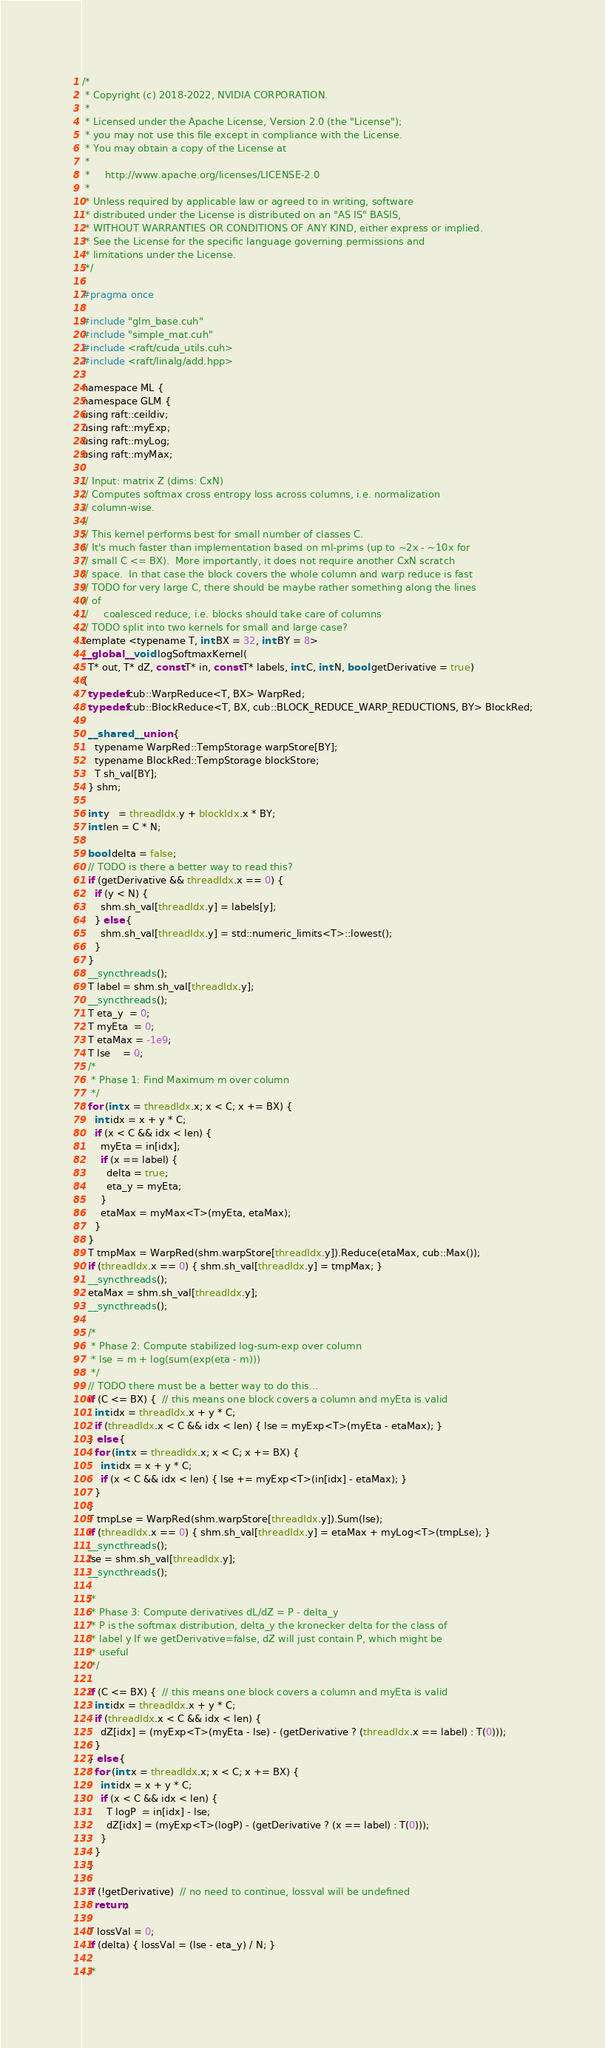Convert code to text. <code><loc_0><loc_0><loc_500><loc_500><_Cuda_>/*
 * Copyright (c) 2018-2022, NVIDIA CORPORATION.
 *
 * Licensed under the Apache License, Version 2.0 (the "License");
 * you may not use this file except in compliance with the License.
 * You may obtain a copy of the License at
 *
 *     http://www.apache.org/licenses/LICENSE-2.0
 *
 * Unless required by applicable law or agreed to in writing, software
 * distributed under the License is distributed on an "AS IS" BASIS,
 * WITHOUT WARRANTIES OR CONDITIONS OF ANY KIND, either express or implied.
 * See the License for the specific language governing permissions and
 * limitations under the License.
 */

#pragma once

#include "glm_base.cuh"
#include "simple_mat.cuh"
#include <raft/cuda_utils.cuh>
#include <raft/linalg/add.hpp>

namespace ML {
namespace GLM {
using raft::ceildiv;
using raft::myExp;
using raft::myLog;
using raft::myMax;

// Input: matrix Z (dims: CxN)
// Computes softmax cross entropy loss across columns, i.e. normalization
// column-wise.
//
// This kernel performs best for small number of classes C.
// It's much faster than implementation based on ml-prims (up to ~2x - ~10x for
// small C <= BX).  More importantly, it does not require another CxN scratch
// space.  In that case the block covers the whole column and warp reduce is fast
// TODO for very large C, there should be maybe rather something along the lines
// of
//     coalesced reduce, i.e. blocks should take care of columns
// TODO split into two kernels for small and large case?
template <typename T, int BX = 32, int BY = 8>
__global__ void logSoftmaxKernel(
  T* out, T* dZ, const T* in, const T* labels, int C, int N, bool getDerivative = true)
{
  typedef cub::WarpReduce<T, BX> WarpRed;
  typedef cub::BlockReduce<T, BX, cub::BLOCK_REDUCE_WARP_REDUCTIONS, BY> BlockRed;

  __shared__ union {
    typename WarpRed::TempStorage warpStore[BY];
    typename BlockRed::TempStorage blockStore;
    T sh_val[BY];
  } shm;

  int y   = threadIdx.y + blockIdx.x * BY;
  int len = C * N;

  bool delta = false;
  // TODO is there a better way to read this?
  if (getDerivative && threadIdx.x == 0) {
    if (y < N) {
      shm.sh_val[threadIdx.y] = labels[y];
    } else {
      shm.sh_val[threadIdx.y] = std::numeric_limits<T>::lowest();
    }
  }
  __syncthreads();
  T label = shm.sh_val[threadIdx.y];
  __syncthreads();
  T eta_y  = 0;
  T myEta  = 0;
  T etaMax = -1e9;
  T lse    = 0;
  /*
   * Phase 1: Find Maximum m over column
   */
  for (int x = threadIdx.x; x < C; x += BX) {
    int idx = x + y * C;
    if (x < C && idx < len) {
      myEta = in[idx];
      if (x == label) {
        delta = true;
        eta_y = myEta;
      }
      etaMax = myMax<T>(myEta, etaMax);
    }
  }
  T tmpMax = WarpRed(shm.warpStore[threadIdx.y]).Reduce(etaMax, cub::Max());
  if (threadIdx.x == 0) { shm.sh_val[threadIdx.y] = tmpMax; }
  __syncthreads();
  etaMax = shm.sh_val[threadIdx.y];
  __syncthreads();

  /*
   * Phase 2: Compute stabilized log-sum-exp over column
   * lse = m + log(sum(exp(eta - m)))
   */
  // TODO there must be a better way to do this...
  if (C <= BX) {  // this means one block covers a column and myEta is valid
    int idx = threadIdx.x + y * C;
    if (threadIdx.x < C && idx < len) { lse = myExp<T>(myEta - etaMax); }
  } else {
    for (int x = threadIdx.x; x < C; x += BX) {
      int idx = x + y * C;
      if (x < C && idx < len) { lse += myExp<T>(in[idx] - etaMax); }
    }
  }
  T tmpLse = WarpRed(shm.warpStore[threadIdx.y]).Sum(lse);
  if (threadIdx.x == 0) { shm.sh_val[threadIdx.y] = etaMax + myLog<T>(tmpLse); }
  __syncthreads();
  lse = shm.sh_val[threadIdx.y];
  __syncthreads();

  /*
   * Phase 3: Compute derivatives dL/dZ = P - delta_y
   * P is the softmax distribution, delta_y the kronecker delta for the class of
   * label y If we getDerivative=false, dZ will just contain P, which might be
   * useful
   */

  if (C <= BX) {  // this means one block covers a column and myEta is valid
    int idx = threadIdx.x + y * C;
    if (threadIdx.x < C && idx < len) {
      dZ[idx] = (myExp<T>(myEta - lse) - (getDerivative ? (threadIdx.x == label) : T(0)));
    }
  } else {
    for (int x = threadIdx.x; x < C; x += BX) {
      int idx = x + y * C;
      if (x < C && idx < len) {
        T logP  = in[idx] - lse;
        dZ[idx] = (myExp<T>(logP) - (getDerivative ? (x == label) : T(0)));
      }
    }
  }

  if (!getDerivative)  // no need to continue, lossval will be undefined
    return;

  T lossVal = 0;
  if (delta) { lossVal = (lse - eta_y) / N; }

  /*</code> 